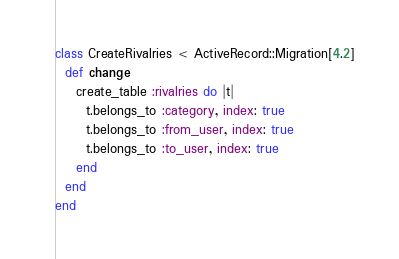Convert code to text. <code><loc_0><loc_0><loc_500><loc_500><_Ruby_>class CreateRivalries < ActiveRecord::Migration[4.2]
  def change
    create_table :rivalries do |t|
      t.belongs_to :category, index: true
      t.belongs_to :from_user, index: true
      t.belongs_to :to_user, index: true
    end
  end
end
</code> 